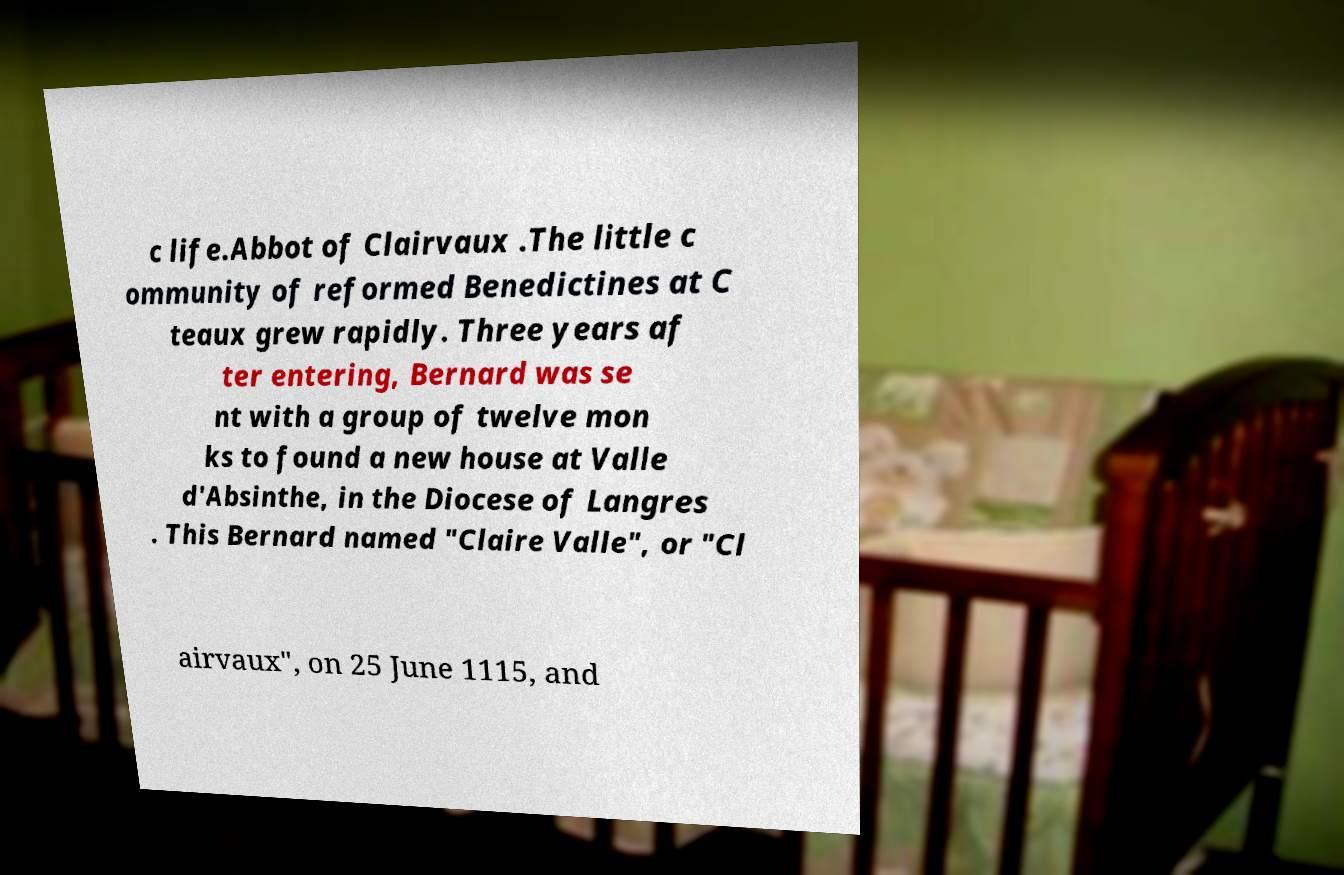Please read and relay the text visible in this image. What does it say? c life.Abbot of Clairvaux .The little c ommunity of reformed Benedictines at C teaux grew rapidly. Three years af ter entering, Bernard was se nt with a group of twelve mon ks to found a new house at Valle d'Absinthe, in the Diocese of Langres . This Bernard named "Claire Valle", or "Cl airvaux", on 25 June 1115, and 